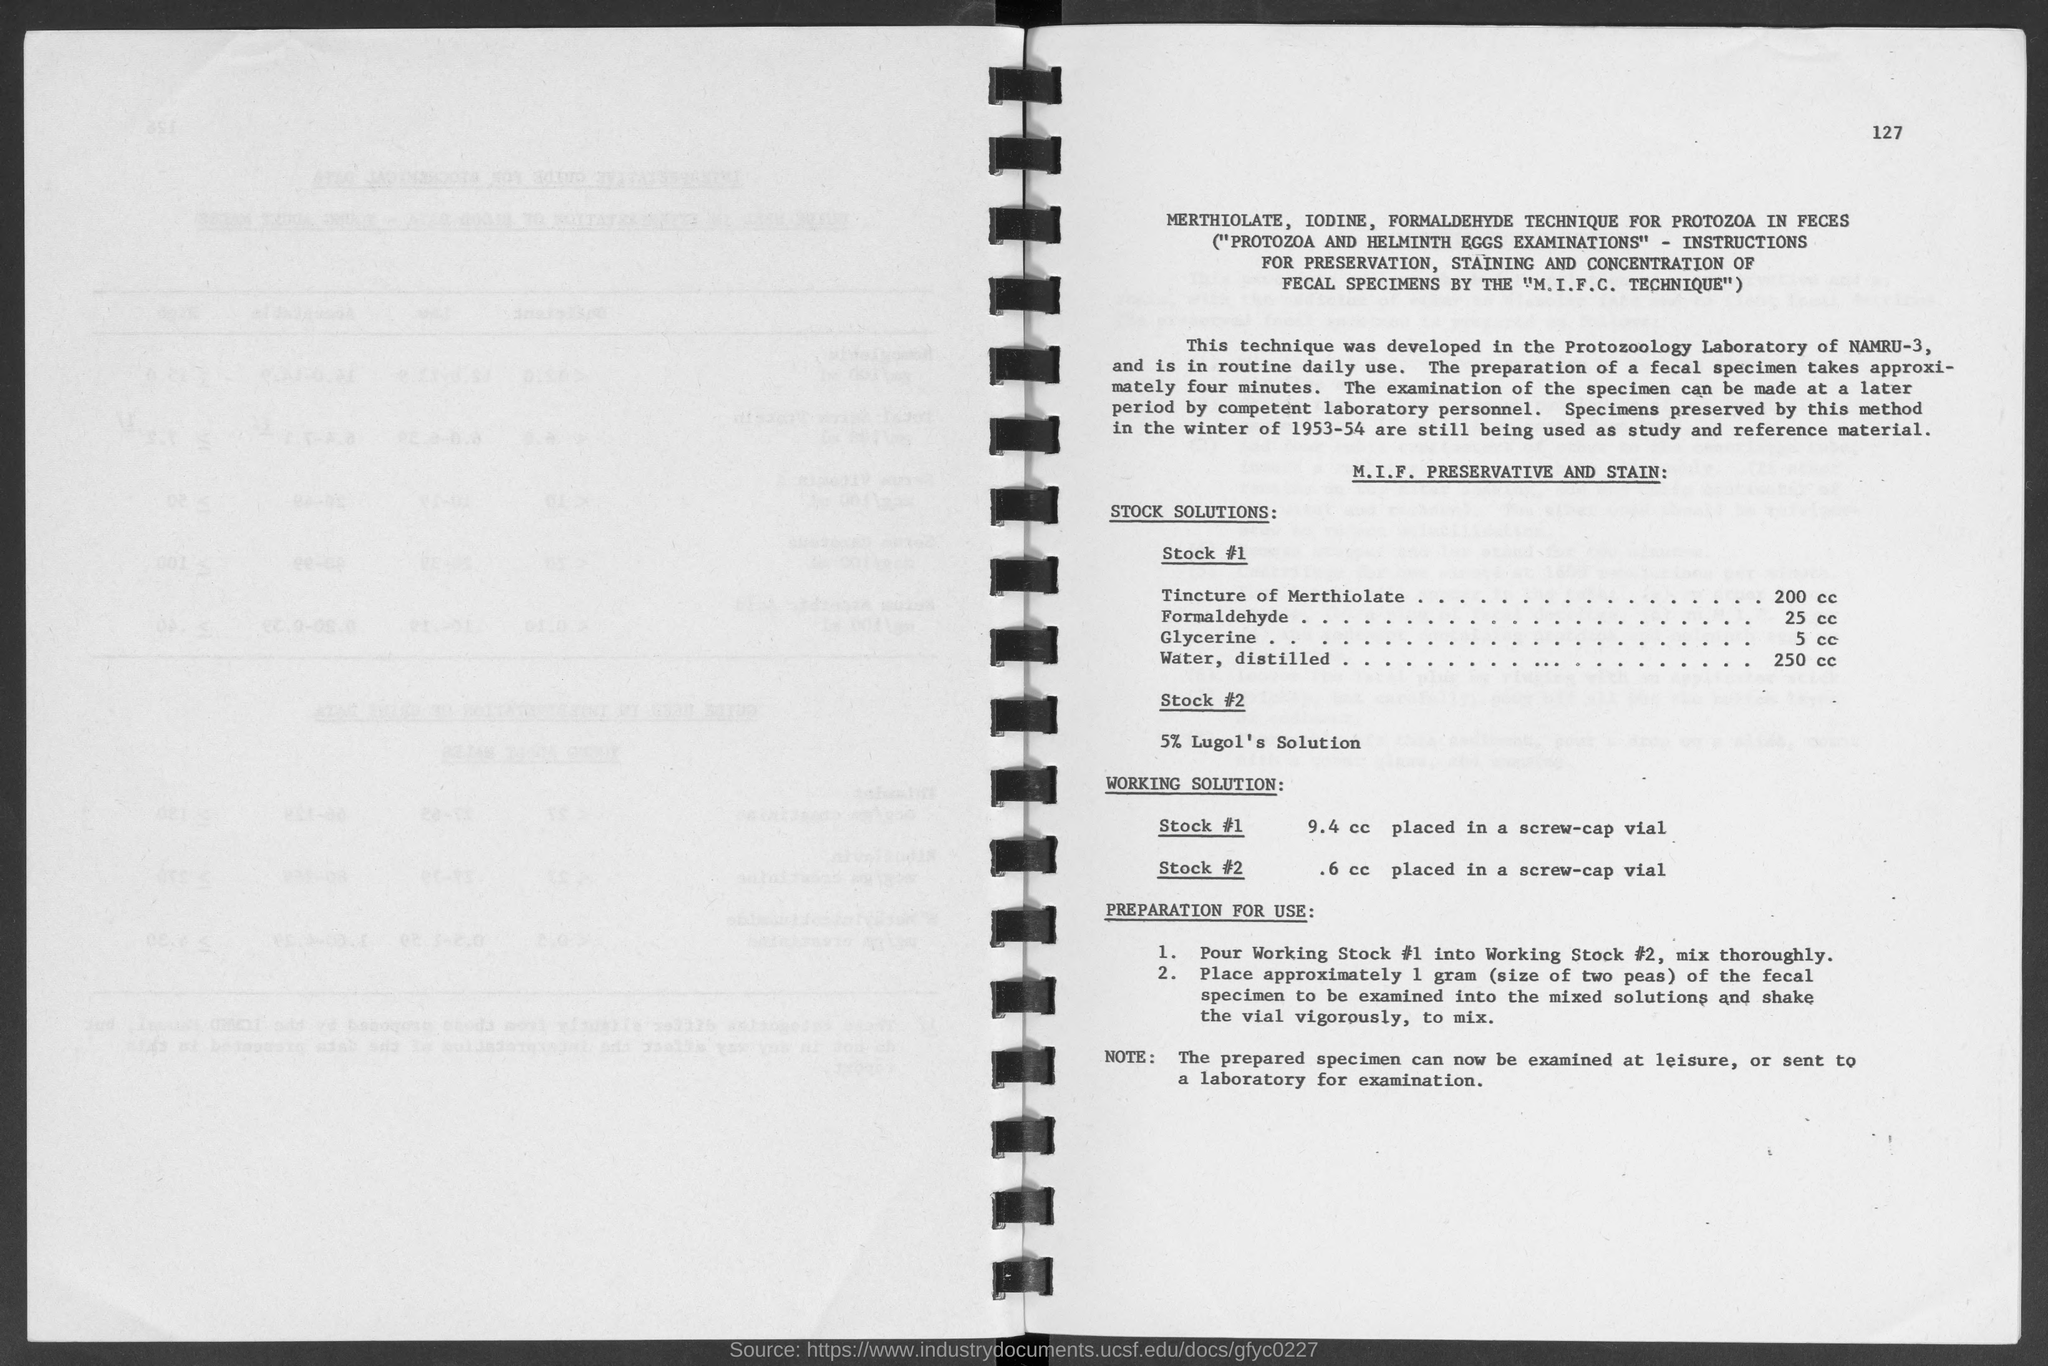Point out several critical features in this image. The amount of glycerine in Stock#1 is 5 cc. The amount of Formaldehyde in Stock #1 is 25 cc. The amount of Tincture of Merthiolate in Stock#1 is 200 cc. On the top-right corner of the page, there is a number that is 127. The amount of water, distilled, is 250 cc. 